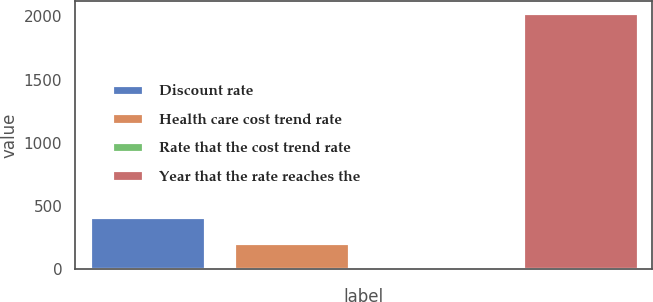<chart> <loc_0><loc_0><loc_500><loc_500><bar_chart><fcel>Discount rate<fcel>Health care cost trend rate<fcel>Rate that the cost trend rate<fcel>Year that the rate reaches the<nl><fcel>409.7<fcel>207.91<fcel>6.12<fcel>2024<nl></chart> 